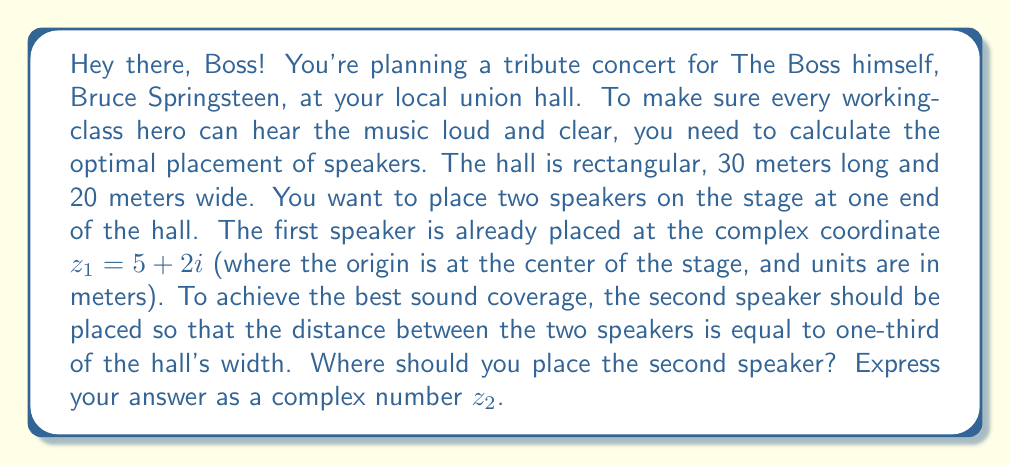Teach me how to tackle this problem. Alright, let's break this down step-by-step, just like Bruce would tackle a new song:

1) We're given that the first speaker is at $z_1 = 5 + 2i$.

2) The hall is 20 meters wide, so the speakers should be $20/3 \approx 6.67$ meters apart.

3) To find $z_2$, we need to find a point that's 6.67 meters away from $z_1$. This forms a circle around $z_1$ with a radius of 6.67.

4) The equation of this circle in the complex plane is:

   $$(z - z_1)(z^* - z_1^*) = r^2$$

   where $z^*$ is the complex conjugate of $z$, and $r = 6.67$.

5) Expanding this:

   $$(x + yi - (5 + 2i))(x - yi - (5 - 2i)) = 6.67^2$$
   $$(x - 5 + y - 2)(x - 5 - y + 2) = 44.4889$$

6) This gives us a circle of possible solutions. To narrow it down, we want the speaker on the same side of the stage, so $x > 5$.

7) The simplest solution that satisfies this is to move 6.67 meters directly to the right of $z_1$. This means adding 6.67 to the real part of $z_1$.

8) Therefore, $z_2 = (5 + 6.67) + 2i = 11.67 + 2i$

So, that's where you should place your second speaker to rock the house, Boss!
Answer: $z_2 = 11.67 + 2i$ 